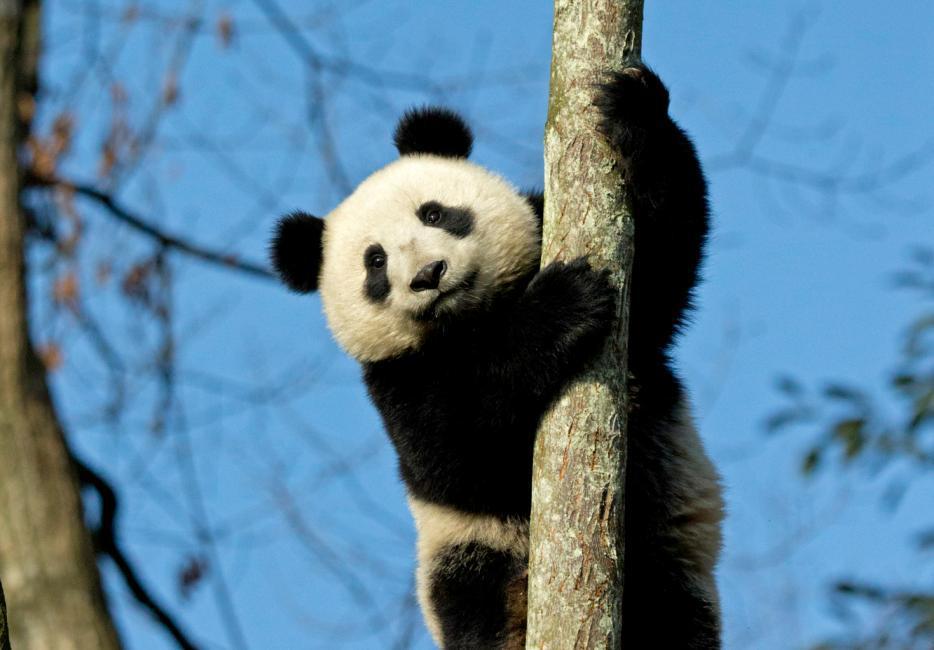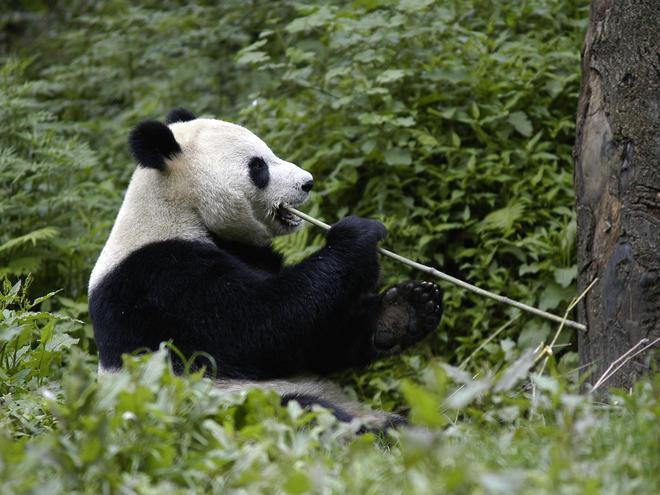The first image is the image on the left, the second image is the image on the right. Given the left and right images, does the statement "There is at least one giant panda sitting in the grass and eating bamboo." hold true? Answer yes or no. Yes. The first image is the image on the left, the second image is the image on the right. Given the left and right images, does the statement "At least one panda is eating." hold true? Answer yes or no. Yes. 